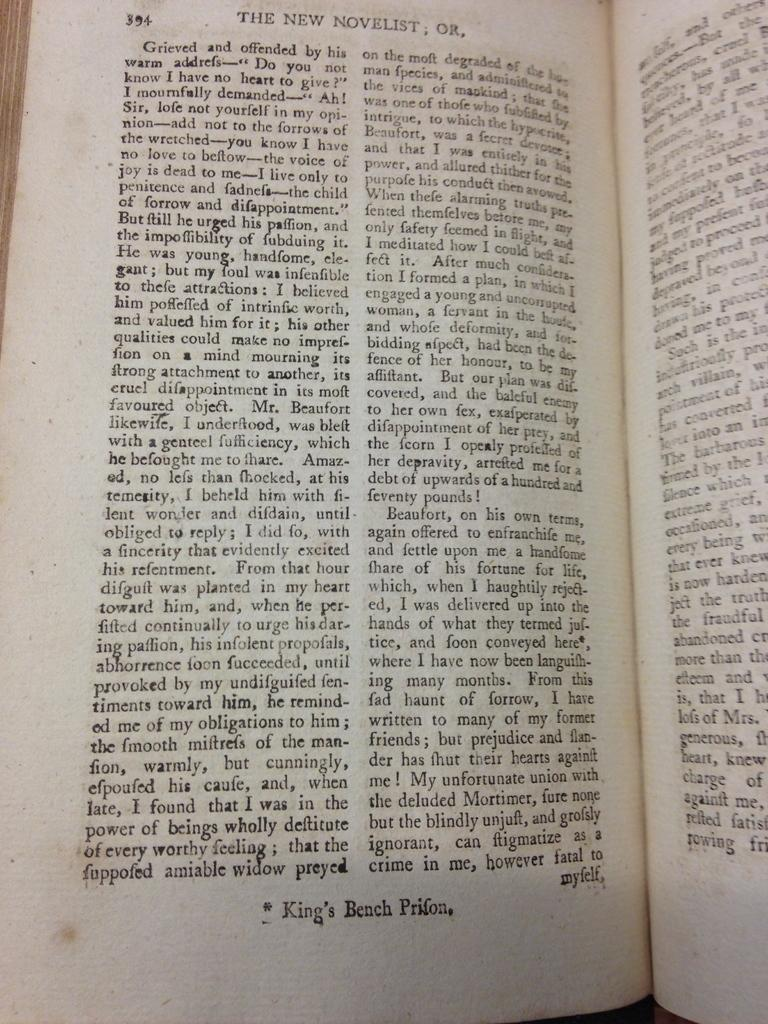What is the main object in the image? There is a book in the image. What type of book is it? The book is a novel. How is the information in the book presented? The book contains information in paragraphs. What type of list can be seen on the cover of the book? There is no list visible on the cover of the book; it is a novel with information presented in paragraphs. 